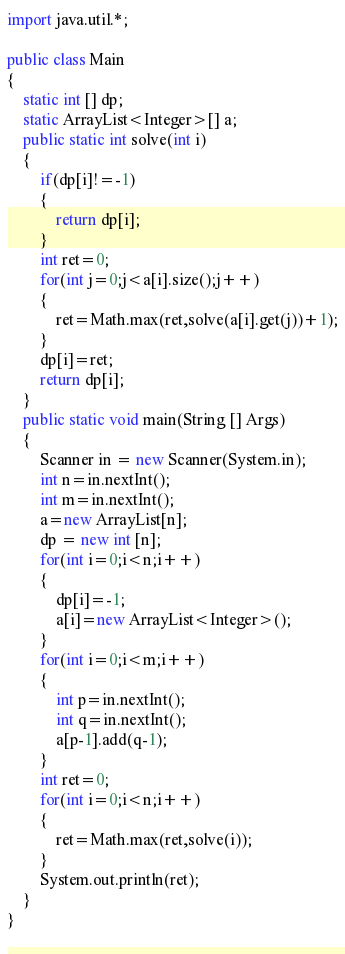<code> <loc_0><loc_0><loc_500><loc_500><_Java_>import java.util.*;

public class Main
{
	static int [] dp;
	static ArrayList<Integer>[] a;
	public static int solve(int i)
	{
		if(dp[i]!=-1)
		{
			return dp[i];
		}
		int ret=0;
		for(int j=0;j<a[i].size();j++)
		{
			ret=Math.max(ret,solve(a[i].get(j))+1);
		}
		dp[i]=ret;
		return dp[i];
	}
	public static void main(String [] Args)
	{
		Scanner in = new Scanner(System.in);
		int n=in.nextInt();
		int m=in.nextInt();
		a=new ArrayList[n];
		dp = new int [n];
		for(int i=0;i<n;i++)
		{
			dp[i]=-1;
			a[i]=new ArrayList<Integer>();
		}
		for(int i=0;i<m;i++)
		{
			int p=in.nextInt();
			int q=in.nextInt();
			a[p-1].add(q-1);
		}
		int ret=0;
		for(int i=0;i<n;i++)
		{
			ret=Math.max(ret,solve(i));
		}
		System.out.println(ret);
	}
}
	</code> 